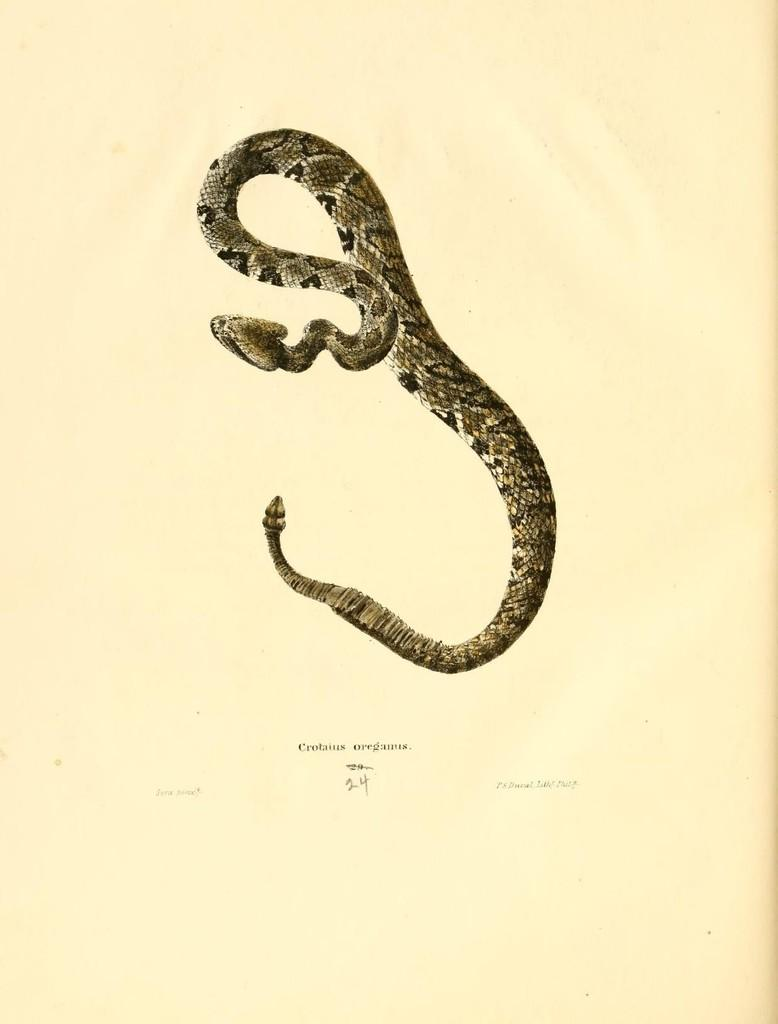What is depicted on the poster in the image? There is a poster of a snake in the image. What color is the background of the image? The background of the image is cream-colored. How many rods are connected to the snake in the image? There are no rods or connections present in the image; it features a poster of a snake with a cream-colored background. 